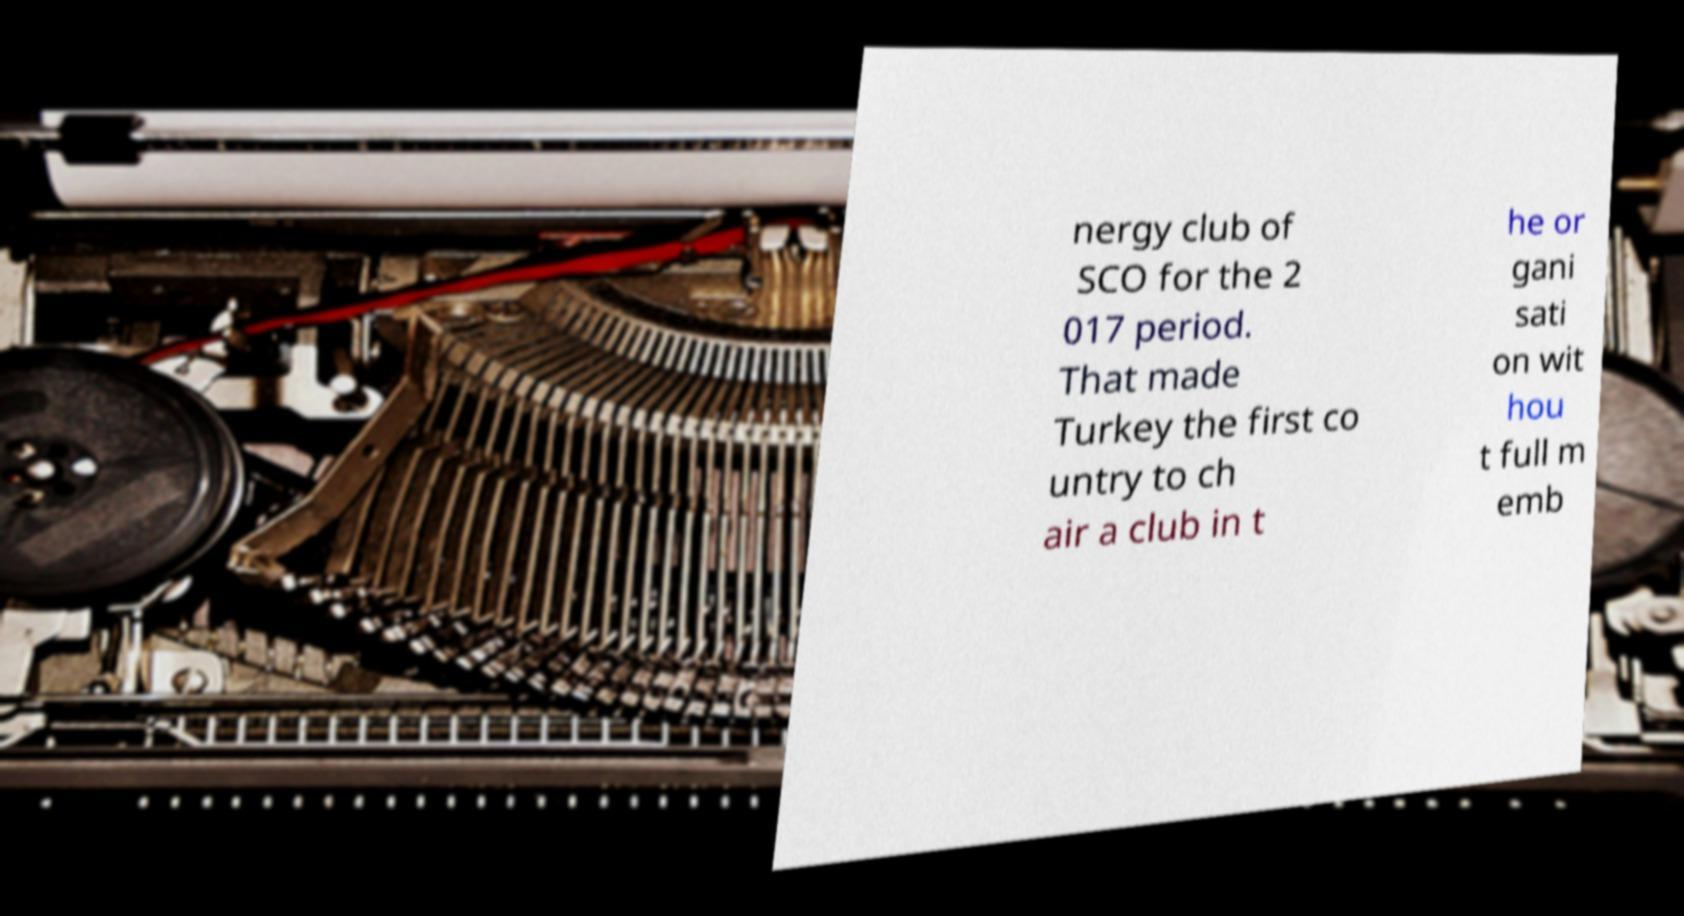I need the written content from this picture converted into text. Can you do that? nergy club of SCO for the 2 017 period. That made Turkey the first co untry to ch air a club in t he or gani sati on wit hou t full m emb 